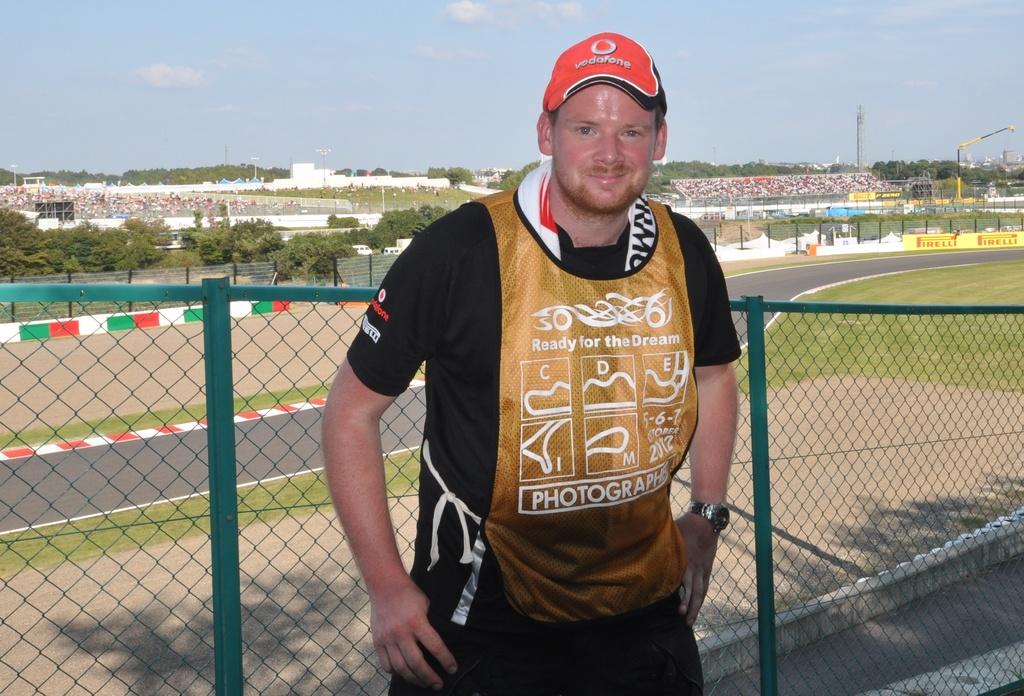What job does this man have?
Ensure brevity in your answer.  Photographer. 